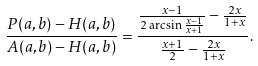<formula> <loc_0><loc_0><loc_500><loc_500>\frac { P ( a , b ) - H ( a , b ) } { A ( a , b ) - H ( a , b ) } & = \frac { \frac { x - 1 } { 2 \arcsin \frac { x - 1 } { x + 1 } } - \frac { 2 x } { 1 + x } } { \frac { x + 1 } { 2 } - \frac { 2 x } { 1 + x } } .</formula> 